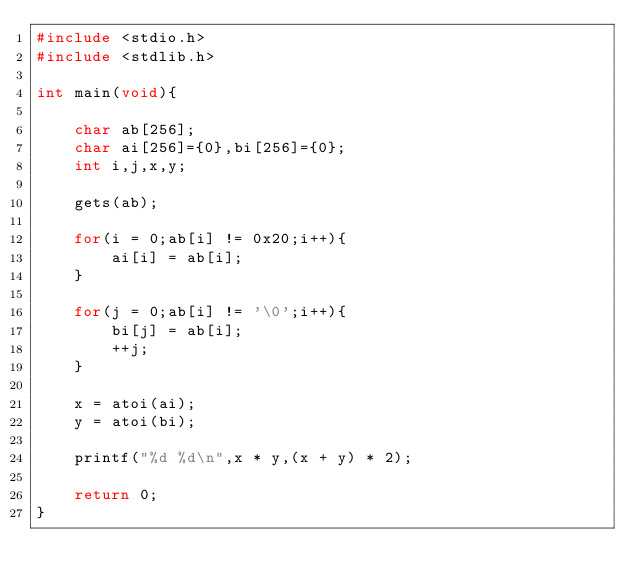Convert code to text. <code><loc_0><loc_0><loc_500><loc_500><_C_>#include <stdio.h>
#include <stdlib.h>

int main(void){

	char ab[256];
	char ai[256]={0},bi[256]={0};
	int i,j,x,y;
	
	gets(ab);
	
	for(i = 0;ab[i] != 0x20;i++){
		ai[i] = ab[i];
	}
	
	for(j = 0;ab[i] != '\0';i++){
		bi[j] = ab[i];
		++j;
	}	
	
	x = atoi(ai);
	y = atoi(bi);
	
	printf("%d %d\n",x * y,(x + y) * 2);
	
	return 0;
}</code> 